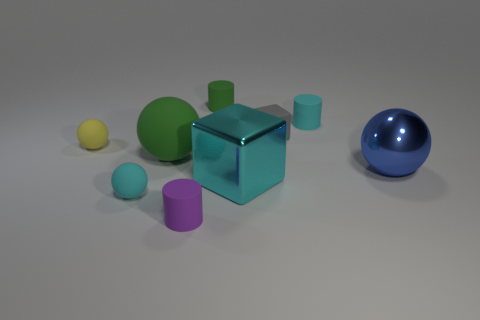What material is the ball that is right of the tiny cyan rubber object that is right of the small purple matte thing?
Offer a terse response. Metal. There is a green rubber thing in front of the yellow sphere; is it the same size as the green rubber thing that is on the right side of the big green matte thing?
Ensure brevity in your answer.  No. Are there any other things that have the same material as the yellow object?
Offer a very short reply. Yes. How many big things are either gray blocks or gray matte cylinders?
Keep it short and to the point. 0. What number of objects are cyan objects on the left side of the large green thing or small green objects?
Give a very brief answer. 2. Does the tiny rubber block have the same color as the large matte ball?
Ensure brevity in your answer.  No. How many other things are there of the same shape as the tiny green rubber thing?
Make the answer very short. 2. How many purple objects are either tiny rubber spheres or tiny objects?
Your answer should be compact. 1. The block that is the same material as the green cylinder is what color?
Your answer should be very brief. Gray. Are the tiny cyan object that is on the right side of the cyan shiny object and the big cyan thing that is on the right side of the tiny yellow matte ball made of the same material?
Offer a terse response. No. 